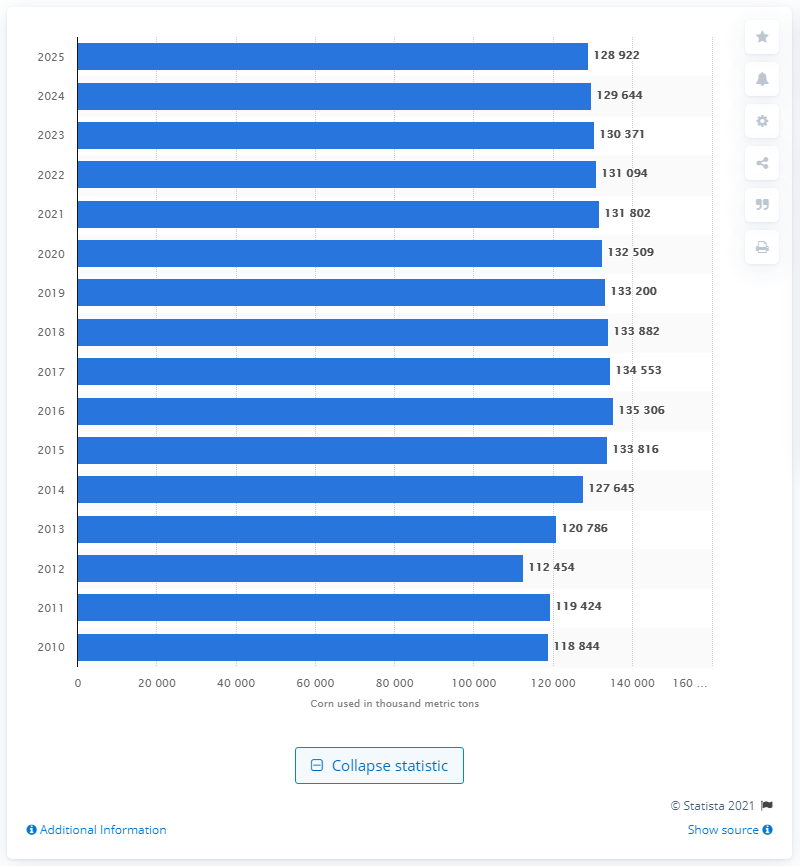Give some essential details in this illustration. In 2010, corn was first used in the production of American ethanol. 